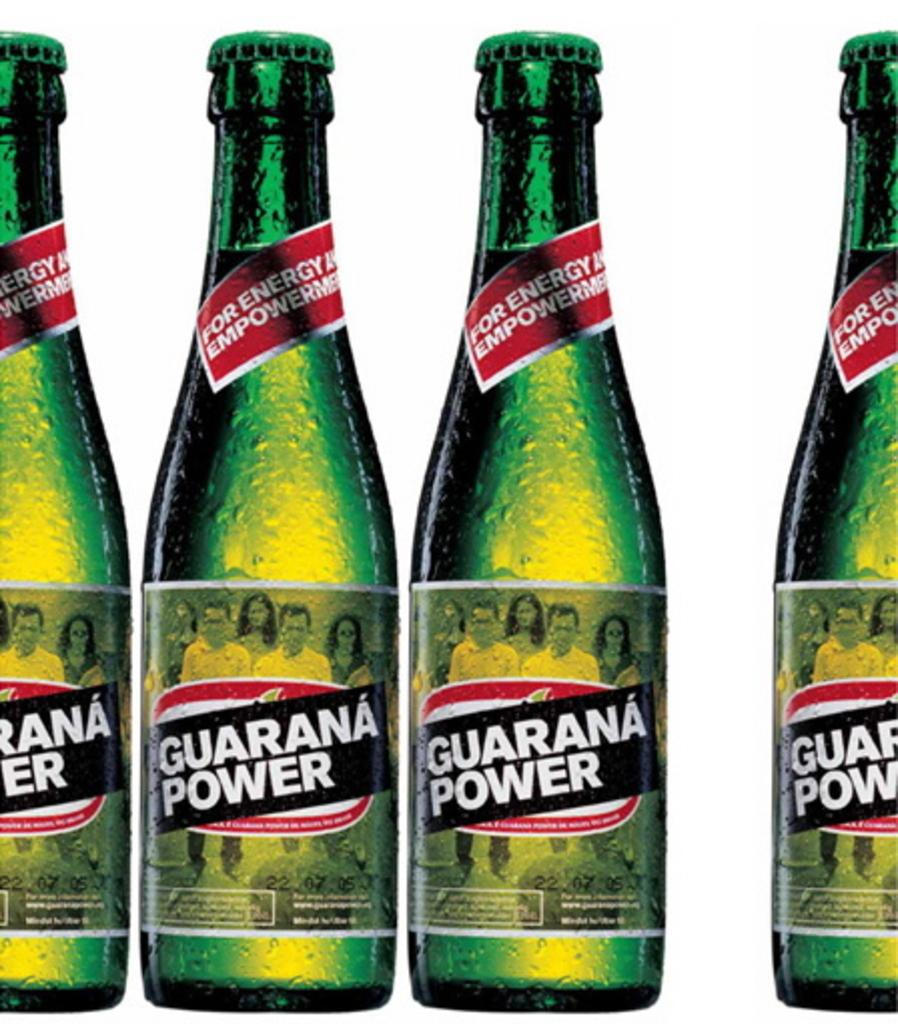<image>
Summarize the visual content of the image. Several bottles of Guarana Power are lined up. 